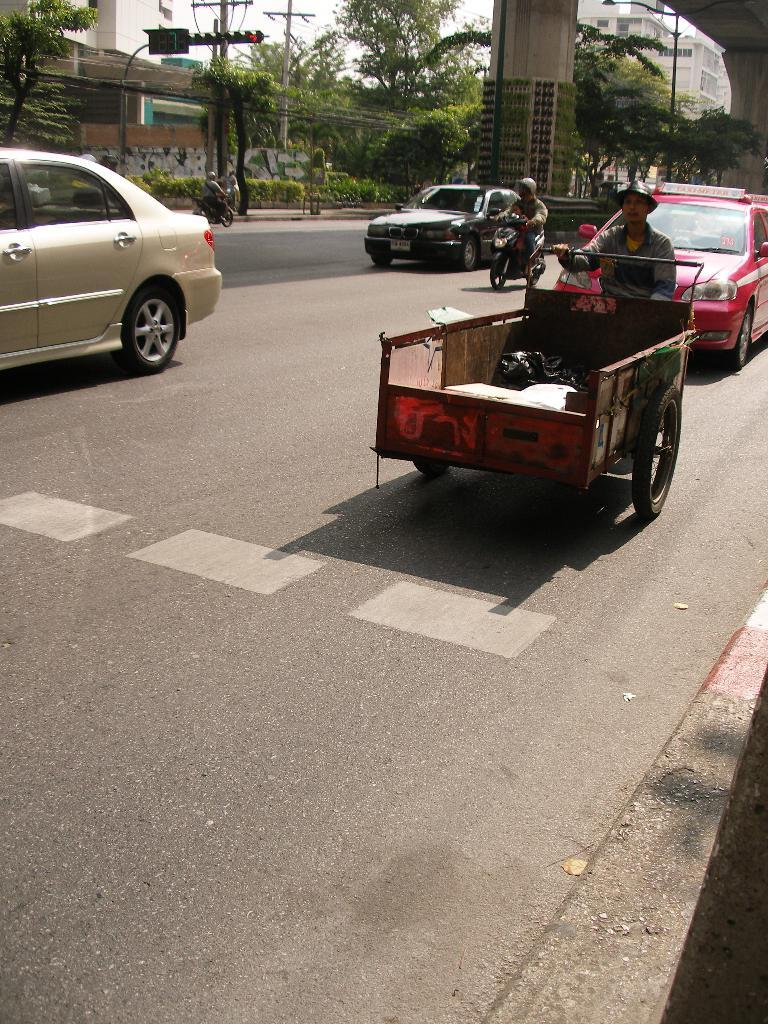What can be seen on the road in the image? There are vehicles on the road in the image. What helps regulate the flow of traffic in the image? There are traffic lights in the image. What type of natural elements can be seen in the background of the image? There are plants, trees, and the sky visible in the background of the image. What type of man-made structures can be seen in the background of the image? There are buildings in the background of the image. What type of tin can be seen hanging from the trees in the image? There is no tin present in the image; it features vehicles, traffic lights, plants, trees, buildings, and the sky. Where is the faucet located in the image? There is no faucet present in the image. 